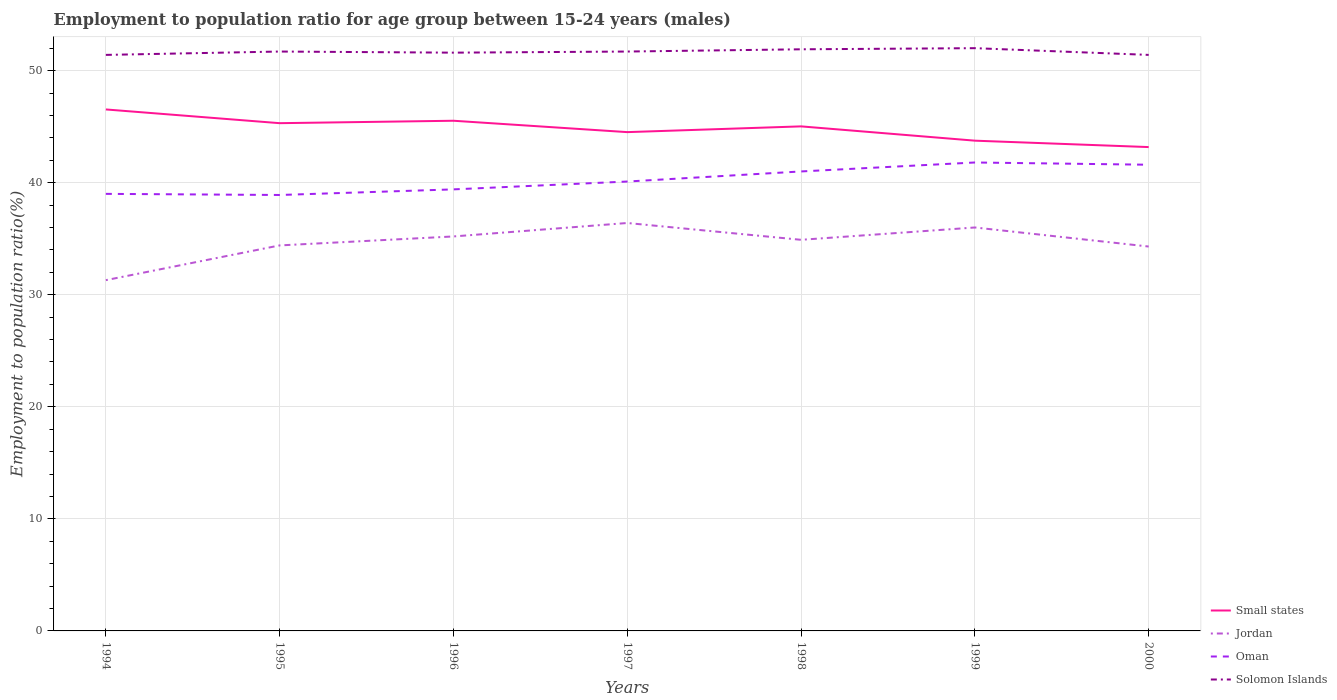Across all years, what is the maximum employment to population ratio in Small states?
Your response must be concise. 43.17. In which year was the employment to population ratio in Small states maximum?
Your response must be concise. 2000. What is the total employment to population ratio in Jordan in the graph?
Ensure brevity in your answer.  -0.8. What is the difference between the highest and the second highest employment to population ratio in Jordan?
Offer a very short reply. 5.1. How many years are there in the graph?
Your response must be concise. 7. What is the difference between two consecutive major ticks on the Y-axis?
Ensure brevity in your answer.  10. Does the graph contain any zero values?
Offer a very short reply. No. Does the graph contain grids?
Provide a short and direct response. Yes. How many legend labels are there?
Your answer should be compact. 4. What is the title of the graph?
Your response must be concise. Employment to population ratio for age group between 15-24 years (males). Does "Norway" appear as one of the legend labels in the graph?
Give a very brief answer. No. What is the label or title of the X-axis?
Your answer should be compact. Years. What is the Employment to population ratio(%) in Small states in 1994?
Your answer should be compact. 46.53. What is the Employment to population ratio(%) in Jordan in 1994?
Give a very brief answer. 31.3. What is the Employment to population ratio(%) in Solomon Islands in 1994?
Provide a short and direct response. 51.4. What is the Employment to population ratio(%) in Small states in 1995?
Provide a short and direct response. 45.31. What is the Employment to population ratio(%) of Jordan in 1995?
Ensure brevity in your answer.  34.4. What is the Employment to population ratio(%) of Oman in 1995?
Your answer should be compact. 38.9. What is the Employment to population ratio(%) in Solomon Islands in 1995?
Make the answer very short. 51.7. What is the Employment to population ratio(%) of Small states in 1996?
Make the answer very short. 45.52. What is the Employment to population ratio(%) in Jordan in 1996?
Make the answer very short. 35.2. What is the Employment to population ratio(%) in Oman in 1996?
Provide a succinct answer. 39.4. What is the Employment to population ratio(%) in Solomon Islands in 1996?
Offer a terse response. 51.6. What is the Employment to population ratio(%) in Small states in 1997?
Keep it short and to the point. 44.51. What is the Employment to population ratio(%) in Jordan in 1997?
Your answer should be very brief. 36.4. What is the Employment to population ratio(%) of Oman in 1997?
Your response must be concise. 40.1. What is the Employment to population ratio(%) of Solomon Islands in 1997?
Your response must be concise. 51.7. What is the Employment to population ratio(%) of Small states in 1998?
Your answer should be compact. 45.02. What is the Employment to population ratio(%) in Jordan in 1998?
Your answer should be compact. 34.9. What is the Employment to population ratio(%) of Solomon Islands in 1998?
Your answer should be very brief. 51.9. What is the Employment to population ratio(%) in Small states in 1999?
Your answer should be compact. 43.75. What is the Employment to population ratio(%) of Jordan in 1999?
Offer a terse response. 36. What is the Employment to population ratio(%) of Oman in 1999?
Give a very brief answer. 41.8. What is the Employment to population ratio(%) of Solomon Islands in 1999?
Your answer should be very brief. 52. What is the Employment to population ratio(%) of Small states in 2000?
Your response must be concise. 43.17. What is the Employment to population ratio(%) in Jordan in 2000?
Offer a terse response. 34.3. What is the Employment to population ratio(%) in Oman in 2000?
Offer a very short reply. 41.6. What is the Employment to population ratio(%) in Solomon Islands in 2000?
Ensure brevity in your answer.  51.4. Across all years, what is the maximum Employment to population ratio(%) of Small states?
Your response must be concise. 46.53. Across all years, what is the maximum Employment to population ratio(%) in Jordan?
Provide a short and direct response. 36.4. Across all years, what is the maximum Employment to population ratio(%) in Oman?
Provide a short and direct response. 41.8. Across all years, what is the minimum Employment to population ratio(%) in Small states?
Keep it short and to the point. 43.17. Across all years, what is the minimum Employment to population ratio(%) of Jordan?
Make the answer very short. 31.3. Across all years, what is the minimum Employment to population ratio(%) in Oman?
Ensure brevity in your answer.  38.9. Across all years, what is the minimum Employment to population ratio(%) of Solomon Islands?
Offer a terse response. 51.4. What is the total Employment to population ratio(%) in Small states in the graph?
Offer a very short reply. 313.82. What is the total Employment to population ratio(%) of Jordan in the graph?
Make the answer very short. 242.5. What is the total Employment to population ratio(%) of Oman in the graph?
Ensure brevity in your answer.  281.8. What is the total Employment to population ratio(%) of Solomon Islands in the graph?
Offer a very short reply. 361.7. What is the difference between the Employment to population ratio(%) in Small states in 1994 and that in 1995?
Make the answer very short. 1.23. What is the difference between the Employment to population ratio(%) of Solomon Islands in 1994 and that in 1995?
Your answer should be very brief. -0.3. What is the difference between the Employment to population ratio(%) in Oman in 1994 and that in 1996?
Provide a succinct answer. -0.4. What is the difference between the Employment to population ratio(%) of Small states in 1994 and that in 1997?
Offer a very short reply. 2.02. What is the difference between the Employment to population ratio(%) in Oman in 1994 and that in 1997?
Offer a terse response. -1.1. What is the difference between the Employment to population ratio(%) of Small states in 1994 and that in 1998?
Keep it short and to the point. 1.51. What is the difference between the Employment to population ratio(%) in Small states in 1994 and that in 1999?
Offer a terse response. 2.79. What is the difference between the Employment to population ratio(%) in Jordan in 1994 and that in 1999?
Provide a succinct answer. -4.7. What is the difference between the Employment to population ratio(%) of Solomon Islands in 1994 and that in 1999?
Provide a succinct answer. -0.6. What is the difference between the Employment to population ratio(%) of Small states in 1994 and that in 2000?
Your answer should be compact. 3.36. What is the difference between the Employment to population ratio(%) in Jordan in 1994 and that in 2000?
Make the answer very short. -3. What is the difference between the Employment to population ratio(%) of Oman in 1994 and that in 2000?
Ensure brevity in your answer.  -2.6. What is the difference between the Employment to population ratio(%) in Solomon Islands in 1994 and that in 2000?
Your answer should be very brief. 0. What is the difference between the Employment to population ratio(%) of Small states in 1995 and that in 1996?
Your answer should be compact. -0.22. What is the difference between the Employment to population ratio(%) of Solomon Islands in 1995 and that in 1996?
Your response must be concise. 0.1. What is the difference between the Employment to population ratio(%) of Small states in 1995 and that in 1997?
Ensure brevity in your answer.  0.8. What is the difference between the Employment to population ratio(%) in Jordan in 1995 and that in 1997?
Keep it short and to the point. -2. What is the difference between the Employment to population ratio(%) in Solomon Islands in 1995 and that in 1997?
Keep it short and to the point. 0. What is the difference between the Employment to population ratio(%) in Small states in 1995 and that in 1998?
Ensure brevity in your answer.  0.29. What is the difference between the Employment to population ratio(%) of Oman in 1995 and that in 1998?
Provide a succinct answer. -2.1. What is the difference between the Employment to population ratio(%) of Solomon Islands in 1995 and that in 1998?
Give a very brief answer. -0.2. What is the difference between the Employment to population ratio(%) of Small states in 1995 and that in 1999?
Your answer should be compact. 1.56. What is the difference between the Employment to population ratio(%) in Oman in 1995 and that in 1999?
Your answer should be very brief. -2.9. What is the difference between the Employment to population ratio(%) of Solomon Islands in 1995 and that in 1999?
Give a very brief answer. -0.3. What is the difference between the Employment to population ratio(%) in Small states in 1995 and that in 2000?
Make the answer very short. 2.13. What is the difference between the Employment to population ratio(%) of Oman in 1995 and that in 2000?
Make the answer very short. -2.7. What is the difference between the Employment to population ratio(%) of Small states in 1996 and that in 1997?
Give a very brief answer. 1.02. What is the difference between the Employment to population ratio(%) in Oman in 1996 and that in 1997?
Your answer should be compact. -0.7. What is the difference between the Employment to population ratio(%) in Solomon Islands in 1996 and that in 1997?
Make the answer very short. -0.1. What is the difference between the Employment to population ratio(%) in Small states in 1996 and that in 1998?
Your response must be concise. 0.5. What is the difference between the Employment to population ratio(%) in Jordan in 1996 and that in 1998?
Your answer should be very brief. 0.3. What is the difference between the Employment to population ratio(%) of Solomon Islands in 1996 and that in 1998?
Provide a succinct answer. -0.3. What is the difference between the Employment to population ratio(%) in Small states in 1996 and that in 1999?
Ensure brevity in your answer.  1.78. What is the difference between the Employment to population ratio(%) in Jordan in 1996 and that in 1999?
Ensure brevity in your answer.  -0.8. What is the difference between the Employment to population ratio(%) of Solomon Islands in 1996 and that in 1999?
Make the answer very short. -0.4. What is the difference between the Employment to population ratio(%) in Small states in 1996 and that in 2000?
Offer a very short reply. 2.35. What is the difference between the Employment to population ratio(%) of Small states in 1997 and that in 1998?
Your answer should be compact. -0.51. What is the difference between the Employment to population ratio(%) in Solomon Islands in 1997 and that in 1998?
Keep it short and to the point. -0.2. What is the difference between the Employment to population ratio(%) of Small states in 1997 and that in 1999?
Give a very brief answer. 0.76. What is the difference between the Employment to population ratio(%) in Jordan in 1997 and that in 1999?
Offer a terse response. 0.4. What is the difference between the Employment to population ratio(%) of Solomon Islands in 1997 and that in 1999?
Give a very brief answer. -0.3. What is the difference between the Employment to population ratio(%) in Small states in 1997 and that in 2000?
Your response must be concise. 1.33. What is the difference between the Employment to population ratio(%) of Jordan in 1997 and that in 2000?
Your response must be concise. 2.1. What is the difference between the Employment to population ratio(%) of Small states in 1998 and that in 1999?
Ensure brevity in your answer.  1.27. What is the difference between the Employment to population ratio(%) of Jordan in 1998 and that in 1999?
Your response must be concise. -1.1. What is the difference between the Employment to population ratio(%) of Small states in 1998 and that in 2000?
Provide a short and direct response. 1.85. What is the difference between the Employment to population ratio(%) in Solomon Islands in 1998 and that in 2000?
Make the answer very short. 0.5. What is the difference between the Employment to population ratio(%) in Small states in 1999 and that in 2000?
Your answer should be compact. 0.57. What is the difference between the Employment to population ratio(%) in Jordan in 1999 and that in 2000?
Ensure brevity in your answer.  1.7. What is the difference between the Employment to population ratio(%) in Oman in 1999 and that in 2000?
Offer a terse response. 0.2. What is the difference between the Employment to population ratio(%) in Solomon Islands in 1999 and that in 2000?
Offer a very short reply. 0.6. What is the difference between the Employment to population ratio(%) of Small states in 1994 and the Employment to population ratio(%) of Jordan in 1995?
Provide a short and direct response. 12.13. What is the difference between the Employment to population ratio(%) of Small states in 1994 and the Employment to population ratio(%) of Oman in 1995?
Offer a terse response. 7.63. What is the difference between the Employment to population ratio(%) in Small states in 1994 and the Employment to population ratio(%) in Solomon Islands in 1995?
Give a very brief answer. -5.17. What is the difference between the Employment to population ratio(%) in Jordan in 1994 and the Employment to population ratio(%) in Solomon Islands in 1995?
Make the answer very short. -20.4. What is the difference between the Employment to population ratio(%) in Oman in 1994 and the Employment to population ratio(%) in Solomon Islands in 1995?
Offer a terse response. -12.7. What is the difference between the Employment to population ratio(%) in Small states in 1994 and the Employment to population ratio(%) in Jordan in 1996?
Provide a succinct answer. 11.33. What is the difference between the Employment to population ratio(%) of Small states in 1994 and the Employment to population ratio(%) of Oman in 1996?
Ensure brevity in your answer.  7.13. What is the difference between the Employment to population ratio(%) of Small states in 1994 and the Employment to population ratio(%) of Solomon Islands in 1996?
Provide a short and direct response. -5.07. What is the difference between the Employment to population ratio(%) in Jordan in 1994 and the Employment to population ratio(%) in Oman in 1996?
Offer a very short reply. -8.1. What is the difference between the Employment to population ratio(%) of Jordan in 1994 and the Employment to population ratio(%) of Solomon Islands in 1996?
Ensure brevity in your answer.  -20.3. What is the difference between the Employment to population ratio(%) in Oman in 1994 and the Employment to population ratio(%) in Solomon Islands in 1996?
Provide a short and direct response. -12.6. What is the difference between the Employment to population ratio(%) of Small states in 1994 and the Employment to population ratio(%) of Jordan in 1997?
Your answer should be very brief. 10.13. What is the difference between the Employment to population ratio(%) of Small states in 1994 and the Employment to population ratio(%) of Oman in 1997?
Offer a very short reply. 6.43. What is the difference between the Employment to population ratio(%) in Small states in 1994 and the Employment to population ratio(%) in Solomon Islands in 1997?
Provide a succinct answer. -5.17. What is the difference between the Employment to population ratio(%) of Jordan in 1994 and the Employment to population ratio(%) of Oman in 1997?
Provide a short and direct response. -8.8. What is the difference between the Employment to population ratio(%) in Jordan in 1994 and the Employment to population ratio(%) in Solomon Islands in 1997?
Provide a short and direct response. -20.4. What is the difference between the Employment to population ratio(%) in Oman in 1994 and the Employment to population ratio(%) in Solomon Islands in 1997?
Provide a succinct answer. -12.7. What is the difference between the Employment to population ratio(%) of Small states in 1994 and the Employment to population ratio(%) of Jordan in 1998?
Give a very brief answer. 11.63. What is the difference between the Employment to population ratio(%) in Small states in 1994 and the Employment to population ratio(%) in Oman in 1998?
Provide a succinct answer. 5.53. What is the difference between the Employment to population ratio(%) of Small states in 1994 and the Employment to population ratio(%) of Solomon Islands in 1998?
Your answer should be very brief. -5.37. What is the difference between the Employment to population ratio(%) in Jordan in 1994 and the Employment to population ratio(%) in Solomon Islands in 1998?
Keep it short and to the point. -20.6. What is the difference between the Employment to population ratio(%) in Small states in 1994 and the Employment to population ratio(%) in Jordan in 1999?
Give a very brief answer. 10.53. What is the difference between the Employment to population ratio(%) of Small states in 1994 and the Employment to population ratio(%) of Oman in 1999?
Give a very brief answer. 4.73. What is the difference between the Employment to population ratio(%) of Small states in 1994 and the Employment to population ratio(%) of Solomon Islands in 1999?
Provide a succinct answer. -5.47. What is the difference between the Employment to population ratio(%) in Jordan in 1994 and the Employment to population ratio(%) in Solomon Islands in 1999?
Your answer should be very brief. -20.7. What is the difference between the Employment to population ratio(%) of Oman in 1994 and the Employment to population ratio(%) of Solomon Islands in 1999?
Provide a short and direct response. -13. What is the difference between the Employment to population ratio(%) of Small states in 1994 and the Employment to population ratio(%) of Jordan in 2000?
Your answer should be compact. 12.23. What is the difference between the Employment to population ratio(%) in Small states in 1994 and the Employment to population ratio(%) in Oman in 2000?
Provide a short and direct response. 4.93. What is the difference between the Employment to population ratio(%) of Small states in 1994 and the Employment to population ratio(%) of Solomon Islands in 2000?
Offer a very short reply. -4.87. What is the difference between the Employment to population ratio(%) in Jordan in 1994 and the Employment to population ratio(%) in Solomon Islands in 2000?
Offer a terse response. -20.1. What is the difference between the Employment to population ratio(%) of Oman in 1994 and the Employment to population ratio(%) of Solomon Islands in 2000?
Ensure brevity in your answer.  -12.4. What is the difference between the Employment to population ratio(%) in Small states in 1995 and the Employment to population ratio(%) in Jordan in 1996?
Offer a very short reply. 10.11. What is the difference between the Employment to population ratio(%) in Small states in 1995 and the Employment to population ratio(%) in Oman in 1996?
Make the answer very short. 5.91. What is the difference between the Employment to population ratio(%) of Small states in 1995 and the Employment to population ratio(%) of Solomon Islands in 1996?
Offer a terse response. -6.29. What is the difference between the Employment to population ratio(%) in Jordan in 1995 and the Employment to population ratio(%) in Solomon Islands in 1996?
Keep it short and to the point. -17.2. What is the difference between the Employment to population ratio(%) in Small states in 1995 and the Employment to population ratio(%) in Jordan in 1997?
Offer a terse response. 8.91. What is the difference between the Employment to population ratio(%) in Small states in 1995 and the Employment to population ratio(%) in Oman in 1997?
Offer a very short reply. 5.21. What is the difference between the Employment to population ratio(%) of Small states in 1995 and the Employment to population ratio(%) of Solomon Islands in 1997?
Provide a succinct answer. -6.39. What is the difference between the Employment to population ratio(%) of Jordan in 1995 and the Employment to population ratio(%) of Solomon Islands in 1997?
Your answer should be very brief. -17.3. What is the difference between the Employment to population ratio(%) in Small states in 1995 and the Employment to population ratio(%) in Jordan in 1998?
Provide a succinct answer. 10.41. What is the difference between the Employment to population ratio(%) in Small states in 1995 and the Employment to population ratio(%) in Oman in 1998?
Offer a very short reply. 4.31. What is the difference between the Employment to population ratio(%) in Small states in 1995 and the Employment to population ratio(%) in Solomon Islands in 1998?
Provide a succinct answer. -6.59. What is the difference between the Employment to population ratio(%) in Jordan in 1995 and the Employment to population ratio(%) in Oman in 1998?
Your answer should be very brief. -6.6. What is the difference between the Employment to population ratio(%) of Jordan in 1995 and the Employment to population ratio(%) of Solomon Islands in 1998?
Give a very brief answer. -17.5. What is the difference between the Employment to population ratio(%) of Oman in 1995 and the Employment to population ratio(%) of Solomon Islands in 1998?
Your answer should be very brief. -13. What is the difference between the Employment to population ratio(%) of Small states in 1995 and the Employment to population ratio(%) of Jordan in 1999?
Keep it short and to the point. 9.31. What is the difference between the Employment to population ratio(%) in Small states in 1995 and the Employment to population ratio(%) in Oman in 1999?
Your answer should be compact. 3.51. What is the difference between the Employment to population ratio(%) in Small states in 1995 and the Employment to population ratio(%) in Solomon Islands in 1999?
Provide a short and direct response. -6.69. What is the difference between the Employment to population ratio(%) in Jordan in 1995 and the Employment to population ratio(%) in Oman in 1999?
Ensure brevity in your answer.  -7.4. What is the difference between the Employment to population ratio(%) in Jordan in 1995 and the Employment to population ratio(%) in Solomon Islands in 1999?
Offer a terse response. -17.6. What is the difference between the Employment to population ratio(%) of Oman in 1995 and the Employment to population ratio(%) of Solomon Islands in 1999?
Offer a terse response. -13.1. What is the difference between the Employment to population ratio(%) in Small states in 1995 and the Employment to population ratio(%) in Jordan in 2000?
Ensure brevity in your answer.  11.01. What is the difference between the Employment to population ratio(%) in Small states in 1995 and the Employment to population ratio(%) in Oman in 2000?
Provide a short and direct response. 3.71. What is the difference between the Employment to population ratio(%) in Small states in 1995 and the Employment to population ratio(%) in Solomon Islands in 2000?
Give a very brief answer. -6.09. What is the difference between the Employment to population ratio(%) in Oman in 1995 and the Employment to population ratio(%) in Solomon Islands in 2000?
Your answer should be very brief. -12.5. What is the difference between the Employment to population ratio(%) of Small states in 1996 and the Employment to population ratio(%) of Jordan in 1997?
Offer a very short reply. 9.12. What is the difference between the Employment to population ratio(%) of Small states in 1996 and the Employment to population ratio(%) of Oman in 1997?
Your answer should be very brief. 5.42. What is the difference between the Employment to population ratio(%) in Small states in 1996 and the Employment to population ratio(%) in Solomon Islands in 1997?
Give a very brief answer. -6.18. What is the difference between the Employment to population ratio(%) of Jordan in 1996 and the Employment to population ratio(%) of Solomon Islands in 1997?
Your answer should be very brief. -16.5. What is the difference between the Employment to population ratio(%) in Oman in 1996 and the Employment to population ratio(%) in Solomon Islands in 1997?
Your answer should be compact. -12.3. What is the difference between the Employment to population ratio(%) in Small states in 1996 and the Employment to population ratio(%) in Jordan in 1998?
Offer a very short reply. 10.62. What is the difference between the Employment to population ratio(%) of Small states in 1996 and the Employment to population ratio(%) of Oman in 1998?
Keep it short and to the point. 4.52. What is the difference between the Employment to population ratio(%) of Small states in 1996 and the Employment to population ratio(%) of Solomon Islands in 1998?
Your answer should be very brief. -6.38. What is the difference between the Employment to population ratio(%) of Jordan in 1996 and the Employment to population ratio(%) of Oman in 1998?
Provide a succinct answer. -5.8. What is the difference between the Employment to population ratio(%) of Jordan in 1996 and the Employment to population ratio(%) of Solomon Islands in 1998?
Provide a succinct answer. -16.7. What is the difference between the Employment to population ratio(%) of Small states in 1996 and the Employment to population ratio(%) of Jordan in 1999?
Offer a very short reply. 9.52. What is the difference between the Employment to population ratio(%) of Small states in 1996 and the Employment to population ratio(%) of Oman in 1999?
Offer a terse response. 3.72. What is the difference between the Employment to population ratio(%) of Small states in 1996 and the Employment to population ratio(%) of Solomon Islands in 1999?
Ensure brevity in your answer.  -6.48. What is the difference between the Employment to population ratio(%) in Jordan in 1996 and the Employment to population ratio(%) in Solomon Islands in 1999?
Ensure brevity in your answer.  -16.8. What is the difference between the Employment to population ratio(%) in Oman in 1996 and the Employment to population ratio(%) in Solomon Islands in 1999?
Your response must be concise. -12.6. What is the difference between the Employment to population ratio(%) in Small states in 1996 and the Employment to population ratio(%) in Jordan in 2000?
Give a very brief answer. 11.22. What is the difference between the Employment to population ratio(%) in Small states in 1996 and the Employment to population ratio(%) in Oman in 2000?
Provide a short and direct response. 3.92. What is the difference between the Employment to population ratio(%) in Small states in 1996 and the Employment to population ratio(%) in Solomon Islands in 2000?
Provide a short and direct response. -5.88. What is the difference between the Employment to population ratio(%) in Jordan in 1996 and the Employment to population ratio(%) in Oman in 2000?
Your response must be concise. -6.4. What is the difference between the Employment to population ratio(%) in Jordan in 1996 and the Employment to population ratio(%) in Solomon Islands in 2000?
Make the answer very short. -16.2. What is the difference between the Employment to population ratio(%) in Small states in 1997 and the Employment to population ratio(%) in Jordan in 1998?
Give a very brief answer. 9.61. What is the difference between the Employment to population ratio(%) of Small states in 1997 and the Employment to population ratio(%) of Oman in 1998?
Keep it short and to the point. 3.51. What is the difference between the Employment to population ratio(%) in Small states in 1997 and the Employment to population ratio(%) in Solomon Islands in 1998?
Give a very brief answer. -7.39. What is the difference between the Employment to population ratio(%) in Jordan in 1997 and the Employment to population ratio(%) in Solomon Islands in 1998?
Keep it short and to the point. -15.5. What is the difference between the Employment to population ratio(%) in Oman in 1997 and the Employment to population ratio(%) in Solomon Islands in 1998?
Your response must be concise. -11.8. What is the difference between the Employment to population ratio(%) in Small states in 1997 and the Employment to population ratio(%) in Jordan in 1999?
Offer a very short reply. 8.51. What is the difference between the Employment to population ratio(%) in Small states in 1997 and the Employment to population ratio(%) in Oman in 1999?
Ensure brevity in your answer.  2.71. What is the difference between the Employment to population ratio(%) in Small states in 1997 and the Employment to population ratio(%) in Solomon Islands in 1999?
Your response must be concise. -7.49. What is the difference between the Employment to population ratio(%) in Jordan in 1997 and the Employment to population ratio(%) in Solomon Islands in 1999?
Provide a succinct answer. -15.6. What is the difference between the Employment to population ratio(%) of Small states in 1997 and the Employment to population ratio(%) of Jordan in 2000?
Your answer should be compact. 10.21. What is the difference between the Employment to population ratio(%) of Small states in 1997 and the Employment to population ratio(%) of Oman in 2000?
Ensure brevity in your answer.  2.91. What is the difference between the Employment to population ratio(%) in Small states in 1997 and the Employment to population ratio(%) in Solomon Islands in 2000?
Provide a short and direct response. -6.89. What is the difference between the Employment to population ratio(%) in Oman in 1997 and the Employment to population ratio(%) in Solomon Islands in 2000?
Provide a short and direct response. -11.3. What is the difference between the Employment to population ratio(%) of Small states in 1998 and the Employment to population ratio(%) of Jordan in 1999?
Your response must be concise. 9.02. What is the difference between the Employment to population ratio(%) of Small states in 1998 and the Employment to population ratio(%) of Oman in 1999?
Offer a very short reply. 3.22. What is the difference between the Employment to population ratio(%) of Small states in 1998 and the Employment to population ratio(%) of Solomon Islands in 1999?
Offer a very short reply. -6.98. What is the difference between the Employment to population ratio(%) of Jordan in 1998 and the Employment to population ratio(%) of Solomon Islands in 1999?
Your answer should be very brief. -17.1. What is the difference between the Employment to population ratio(%) of Small states in 1998 and the Employment to population ratio(%) of Jordan in 2000?
Your answer should be very brief. 10.72. What is the difference between the Employment to population ratio(%) of Small states in 1998 and the Employment to population ratio(%) of Oman in 2000?
Your answer should be very brief. 3.42. What is the difference between the Employment to population ratio(%) in Small states in 1998 and the Employment to population ratio(%) in Solomon Islands in 2000?
Keep it short and to the point. -6.38. What is the difference between the Employment to population ratio(%) in Jordan in 1998 and the Employment to population ratio(%) in Oman in 2000?
Your answer should be compact. -6.7. What is the difference between the Employment to population ratio(%) of Jordan in 1998 and the Employment to population ratio(%) of Solomon Islands in 2000?
Provide a short and direct response. -16.5. What is the difference between the Employment to population ratio(%) of Small states in 1999 and the Employment to population ratio(%) of Jordan in 2000?
Give a very brief answer. 9.45. What is the difference between the Employment to population ratio(%) in Small states in 1999 and the Employment to population ratio(%) in Oman in 2000?
Provide a succinct answer. 2.15. What is the difference between the Employment to population ratio(%) of Small states in 1999 and the Employment to population ratio(%) of Solomon Islands in 2000?
Your answer should be compact. -7.65. What is the difference between the Employment to population ratio(%) of Jordan in 1999 and the Employment to population ratio(%) of Oman in 2000?
Offer a very short reply. -5.6. What is the difference between the Employment to population ratio(%) of Jordan in 1999 and the Employment to population ratio(%) of Solomon Islands in 2000?
Offer a terse response. -15.4. What is the average Employment to population ratio(%) in Small states per year?
Your answer should be compact. 44.83. What is the average Employment to population ratio(%) in Jordan per year?
Ensure brevity in your answer.  34.64. What is the average Employment to population ratio(%) of Oman per year?
Make the answer very short. 40.26. What is the average Employment to population ratio(%) of Solomon Islands per year?
Offer a very short reply. 51.67. In the year 1994, what is the difference between the Employment to population ratio(%) in Small states and Employment to population ratio(%) in Jordan?
Provide a short and direct response. 15.23. In the year 1994, what is the difference between the Employment to population ratio(%) in Small states and Employment to population ratio(%) in Oman?
Offer a very short reply. 7.53. In the year 1994, what is the difference between the Employment to population ratio(%) of Small states and Employment to population ratio(%) of Solomon Islands?
Offer a very short reply. -4.87. In the year 1994, what is the difference between the Employment to population ratio(%) of Jordan and Employment to population ratio(%) of Oman?
Make the answer very short. -7.7. In the year 1994, what is the difference between the Employment to population ratio(%) of Jordan and Employment to population ratio(%) of Solomon Islands?
Provide a short and direct response. -20.1. In the year 1995, what is the difference between the Employment to population ratio(%) of Small states and Employment to population ratio(%) of Jordan?
Your answer should be compact. 10.91. In the year 1995, what is the difference between the Employment to population ratio(%) in Small states and Employment to population ratio(%) in Oman?
Provide a succinct answer. 6.41. In the year 1995, what is the difference between the Employment to population ratio(%) of Small states and Employment to population ratio(%) of Solomon Islands?
Offer a very short reply. -6.39. In the year 1995, what is the difference between the Employment to population ratio(%) of Jordan and Employment to population ratio(%) of Solomon Islands?
Offer a very short reply. -17.3. In the year 1996, what is the difference between the Employment to population ratio(%) in Small states and Employment to population ratio(%) in Jordan?
Provide a succinct answer. 10.32. In the year 1996, what is the difference between the Employment to population ratio(%) in Small states and Employment to population ratio(%) in Oman?
Provide a succinct answer. 6.12. In the year 1996, what is the difference between the Employment to population ratio(%) of Small states and Employment to population ratio(%) of Solomon Islands?
Provide a succinct answer. -6.08. In the year 1996, what is the difference between the Employment to population ratio(%) of Jordan and Employment to population ratio(%) of Solomon Islands?
Offer a very short reply. -16.4. In the year 1996, what is the difference between the Employment to population ratio(%) in Oman and Employment to population ratio(%) in Solomon Islands?
Provide a succinct answer. -12.2. In the year 1997, what is the difference between the Employment to population ratio(%) in Small states and Employment to population ratio(%) in Jordan?
Make the answer very short. 8.11. In the year 1997, what is the difference between the Employment to population ratio(%) in Small states and Employment to population ratio(%) in Oman?
Provide a short and direct response. 4.41. In the year 1997, what is the difference between the Employment to population ratio(%) in Small states and Employment to population ratio(%) in Solomon Islands?
Your answer should be compact. -7.19. In the year 1997, what is the difference between the Employment to population ratio(%) in Jordan and Employment to population ratio(%) in Oman?
Provide a succinct answer. -3.7. In the year 1997, what is the difference between the Employment to population ratio(%) in Jordan and Employment to population ratio(%) in Solomon Islands?
Your response must be concise. -15.3. In the year 1997, what is the difference between the Employment to population ratio(%) of Oman and Employment to population ratio(%) of Solomon Islands?
Offer a very short reply. -11.6. In the year 1998, what is the difference between the Employment to population ratio(%) of Small states and Employment to population ratio(%) of Jordan?
Offer a terse response. 10.12. In the year 1998, what is the difference between the Employment to population ratio(%) of Small states and Employment to population ratio(%) of Oman?
Give a very brief answer. 4.02. In the year 1998, what is the difference between the Employment to population ratio(%) in Small states and Employment to population ratio(%) in Solomon Islands?
Give a very brief answer. -6.88. In the year 1998, what is the difference between the Employment to population ratio(%) in Jordan and Employment to population ratio(%) in Solomon Islands?
Offer a terse response. -17. In the year 1998, what is the difference between the Employment to population ratio(%) in Oman and Employment to population ratio(%) in Solomon Islands?
Keep it short and to the point. -10.9. In the year 1999, what is the difference between the Employment to population ratio(%) in Small states and Employment to population ratio(%) in Jordan?
Ensure brevity in your answer.  7.75. In the year 1999, what is the difference between the Employment to population ratio(%) of Small states and Employment to population ratio(%) of Oman?
Give a very brief answer. 1.95. In the year 1999, what is the difference between the Employment to population ratio(%) of Small states and Employment to population ratio(%) of Solomon Islands?
Your answer should be very brief. -8.25. In the year 1999, what is the difference between the Employment to population ratio(%) of Jordan and Employment to population ratio(%) of Oman?
Your answer should be compact. -5.8. In the year 1999, what is the difference between the Employment to population ratio(%) of Jordan and Employment to population ratio(%) of Solomon Islands?
Offer a very short reply. -16. In the year 2000, what is the difference between the Employment to population ratio(%) in Small states and Employment to population ratio(%) in Jordan?
Make the answer very short. 8.87. In the year 2000, what is the difference between the Employment to population ratio(%) in Small states and Employment to population ratio(%) in Oman?
Ensure brevity in your answer.  1.57. In the year 2000, what is the difference between the Employment to population ratio(%) of Small states and Employment to population ratio(%) of Solomon Islands?
Make the answer very short. -8.23. In the year 2000, what is the difference between the Employment to population ratio(%) of Jordan and Employment to population ratio(%) of Oman?
Your response must be concise. -7.3. In the year 2000, what is the difference between the Employment to population ratio(%) of Jordan and Employment to population ratio(%) of Solomon Islands?
Your answer should be very brief. -17.1. What is the ratio of the Employment to population ratio(%) in Small states in 1994 to that in 1995?
Your answer should be compact. 1.03. What is the ratio of the Employment to population ratio(%) in Jordan in 1994 to that in 1995?
Your response must be concise. 0.91. What is the ratio of the Employment to population ratio(%) of Oman in 1994 to that in 1995?
Offer a very short reply. 1. What is the ratio of the Employment to population ratio(%) in Small states in 1994 to that in 1996?
Your response must be concise. 1.02. What is the ratio of the Employment to population ratio(%) of Jordan in 1994 to that in 1996?
Keep it short and to the point. 0.89. What is the ratio of the Employment to population ratio(%) in Small states in 1994 to that in 1997?
Your answer should be very brief. 1.05. What is the ratio of the Employment to population ratio(%) of Jordan in 1994 to that in 1997?
Give a very brief answer. 0.86. What is the ratio of the Employment to population ratio(%) of Oman in 1994 to that in 1997?
Give a very brief answer. 0.97. What is the ratio of the Employment to population ratio(%) in Small states in 1994 to that in 1998?
Offer a terse response. 1.03. What is the ratio of the Employment to population ratio(%) of Jordan in 1994 to that in 1998?
Ensure brevity in your answer.  0.9. What is the ratio of the Employment to population ratio(%) in Oman in 1994 to that in 1998?
Your answer should be compact. 0.95. What is the ratio of the Employment to population ratio(%) of Small states in 1994 to that in 1999?
Keep it short and to the point. 1.06. What is the ratio of the Employment to population ratio(%) of Jordan in 1994 to that in 1999?
Keep it short and to the point. 0.87. What is the ratio of the Employment to population ratio(%) of Oman in 1994 to that in 1999?
Your answer should be compact. 0.93. What is the ratio of the Employment to population ratio(%) in Small states in 1994 to that in 2000?
Your answer should be compact. 1.08. What is the ratio of the Employment to population ratio(%) in Jordan in 1994 to that in 2000?
Provide a succinct answer. 0.91. What is the ratio of the Employment to population ratio(%) in Solomon Islands in 1994 to that in 2000?
Keep it short and to the point. 1. What is the ratio of the Employment to population ratio(%) of Jordan in 1995 to that in 1996?
Make the answer very short. 0.98. What is the ratio of the Employment to population ratio(%) in Oman in 1995 to that in 1996?
Give a very brief answer. 0.99. What is the ratio of the Employment to population ratio(%) of Solomon Islands in 1995 to that in 1996?
Ensure brevity in your answer.  1. What is the ratio of the Employment to population ratio(%) of Small states in 1995 to that in 1997?
Your answer should be very brief. 1.02. What is the ratio of the Employment to population ratio(%) in Jordan in 1995 to that in 1997?
Provide a succinct answer. 0.95. What is the ratio of the Employment to population ratio(%) in Oman in 1995 to that in 1997?
Provide a short and direct response. 0.97. What is the ratio of the Employment to population ratio(%) of Solomon Islands in 1995 to that in 1997?
Your answer should be compact. 1. What is the ratio of the Employment to population ratio(%) in Jordan in 1995 to that in 1998?
Give a very brief answer. 0.99. What is the ratio of the Employment to population ratio(%) in Oman in 1995 to that in 1998?
Give a very brief answer. 0.95. What is the ratio of the Employment to population ratio(%) in Solomon Islands in 1995 to that in 1998?
Offer a very short reply. 1. What is the ratio of the Employment to population ratio(%) of Small states in 1995 to that in 1999?
Your answer should be compact. 1.04. What is the ratio of the Employment to population ratio(%) in Jordan in 1995 to that in 1999?
Offer a terse response. 0.96. What is the ratio of the Employment to population ratio(%) of Oman in 1995 to that in 1999?
Give a very brief answer. 0.93. What is the ratio of the Employment to population ratio(%) of Small states in 1995 to that in 2000?
Offer a very short reply. 1.05. What is the ratio of the Employment to population ratio(%) in Jordan in 1995 to that in 2000?
Provide a short and direct response. 1. What is the ratio of the Employment to population ratio(%) of Oman in 1995 to that in 2000?
Give a very brief answer. 0.94. What is the ratio of the Employment to population ratio(%) of Solomon Islands in 1995 to that in 2000?
Offer a very short reply. 1.01. What is the ratio of the Employment to population ratio(%) in Small states in 1996 to that in 1997?
Provide a succinct answer. 1.02. What is the ratio of the Employment to population ratio(%) of Jordan in 1996 to that in 1997?
Make the answer very short. 0.97. What is the ratio of the Employment to population ratio(%) of Oman in 1996 to that in 1997?
Give a very brief answer. 0.98. What is the ratio of the Employment to population ratio(%) in Solomon Islands in 1996 to that in 1997?
Make the answer very short. 1. What is the ratio of the Employment to population ratio(%) in Small states in 1996 to that in 1998?
Give a very brief answer. 1.01. What is the ratio of the Employment to population ratio(%) in Jordan in 1996 to that in 1998?
Keep it short and to the point. 1.01. What is the ratio of the Employment to population ratio(%) of Solomon Islands in 1996 to that in 1998?
Give a very brief answer. 0.99. What is the ratio of the Employment to population ratio(%) in Small states in 1996 to that in 1999?
Make the answer very short. 1.04. What is the ratio of the Employment to population ratio(%) of Jordan in 1996 to that in 1999?
Your response must be concise. 0.98. What is the ratio of the Employment to population ratio(%) in Oman in 1996 to that in 1999?
Ensure brevity in your answer.  0.94. What is the ratio of the Employment to population ratio(%) of Solomon Islands in 1996 to that in 1999?
Give a very brief answer. 0.99. What is the ratio of the Employment to population ratio(%) of Small states in 1996 to that in 2000?
Give a very brief answer. 1.05. What is the ratio of the Employment to population ratio(%) in Jordan in 1996 to that in 2000?
Give a very brief answer. 1.03. What is the ratio of the Employment to population ratio(%) in Oman in 1996 to that in 2000?
Provide a succinct answer. 0.95. What is the ratio of the Employment to population ratio(%) of Small states in 1997 to that in 1998?
Offer a very short reply. 0.99. What is the ratio of the Employment to population ratio(%) in Jordan in 1997 to that in 1998?
Offer a terse response. 1.04. What is the ratio of the Employment to population ratio(%) in Oman in 1997 to that in 1998?
Provide a succinct answer. 0.98. What is the ratio of the Employment to population ratio(%) in Solomon Islands in 1997 to that in 1998?
Your answer should be very brief. 1. What is the ratio of the Employment to population ratio(%) of Small states in 1997 to that in 1999?
Your response must be concise. 1.02. What is the ratio of the Employment to population ratio(%) of Jordan in 1997 to that in 1999?
Give a very brief answer. 1.01. What is the ratio of the Employment to population ratio(%) in Oman in 1997 to that in 1999?
Offer a terse response. 0.96. What is the ratio of the Employment to population ratio(%) of Small states in 1997 to that in 2000?
Your answer should be very brief. 1.03. What is the ratio of the Employment to population ratio(%) in Jordan in 1997 to that in 2000?
Offer a terse response. 1.06. What is the ratio of the Employment to population ratio(%) in Oman in 1997 to that in 2000?
Keep it short and to the point. 0.96. What is the ratio of the Employment to population ratio(%) in Small states in 1998 to that in 1999?
Ensure brevity in your answer.  1.03. What is the ratio of the Employment to population ratio(%) of Jordan in 1998 to that in 1999?
Offer a very short reply. 0.97. What is the ratio of the Employment to population ratio(%) in Oman in 1998 to that in 1999?
Ensure brevity in your answer.  0.98. What is the ratio of the Employment to population ratio(%) in Solomon Islands in 1998 to that in 1999?
Provide a short and direct response. 1. What is the ratio of the Employment to population ratio(%) of Small states in 1998 to that in 2000?
Offer a terse response. 1.04. What is the ratio of the Employment to population ratio(%) in Jordan in 1998 to that in 2000?
Your response must be concise. 1.02. What is the ratio of the Employment to population ratio(%) in Oman in 1998 to that in 2000?
Offer a terse response. 0.99. What is the ratio of the Employment to population ratio(%) of Solomon Islands in 1998 to that in 2000?
Give a very brief answer. 1.01. What is the ratio of the Employment to population ratio(%) of Small states in 1999 to that in 2000?
Your answer should be very brief. 1.01. What is the ratio of the Employment to population ratio(%) in Jordan in 1999 to that in 2000?
Provide a short and direct response. 1.05. What is the ratio of the Employment to population ratio(%) in Oman in 1999 to that in 2000?
Give a very brief answer. 1. What is the ratio of the Employment to population ratio(%) in Solomon Islands in 1999 to that in 2000?
Keep it short and to the point. 1.01. What is the difference between the highest and the second highest Employment to population ratio(%) in Small states?
Keep it short and to the point. 1.01. What is the difference between the highest and the second highest Employment to population ratio(%) of Jordan?
Ensure brevity in your answer.  0.4. What is the difference between the highest and the second highest Employment to population ratio(%) of Oman?
Offer a terse response. 0.2. What is the difference between the highest and the second highest Employment to population ratio(%) of Solomon Islands?
Make the answer very short. 0.1. What is the difference between the highest and the lowest Employment to population ratio(%) in Small states?
Offer a terse response. 3.36. What is the difference between the highest and the lowest Employment to population ratio(%) in Solomon Islands?
Ensure brevity in your answer.  0.6. 